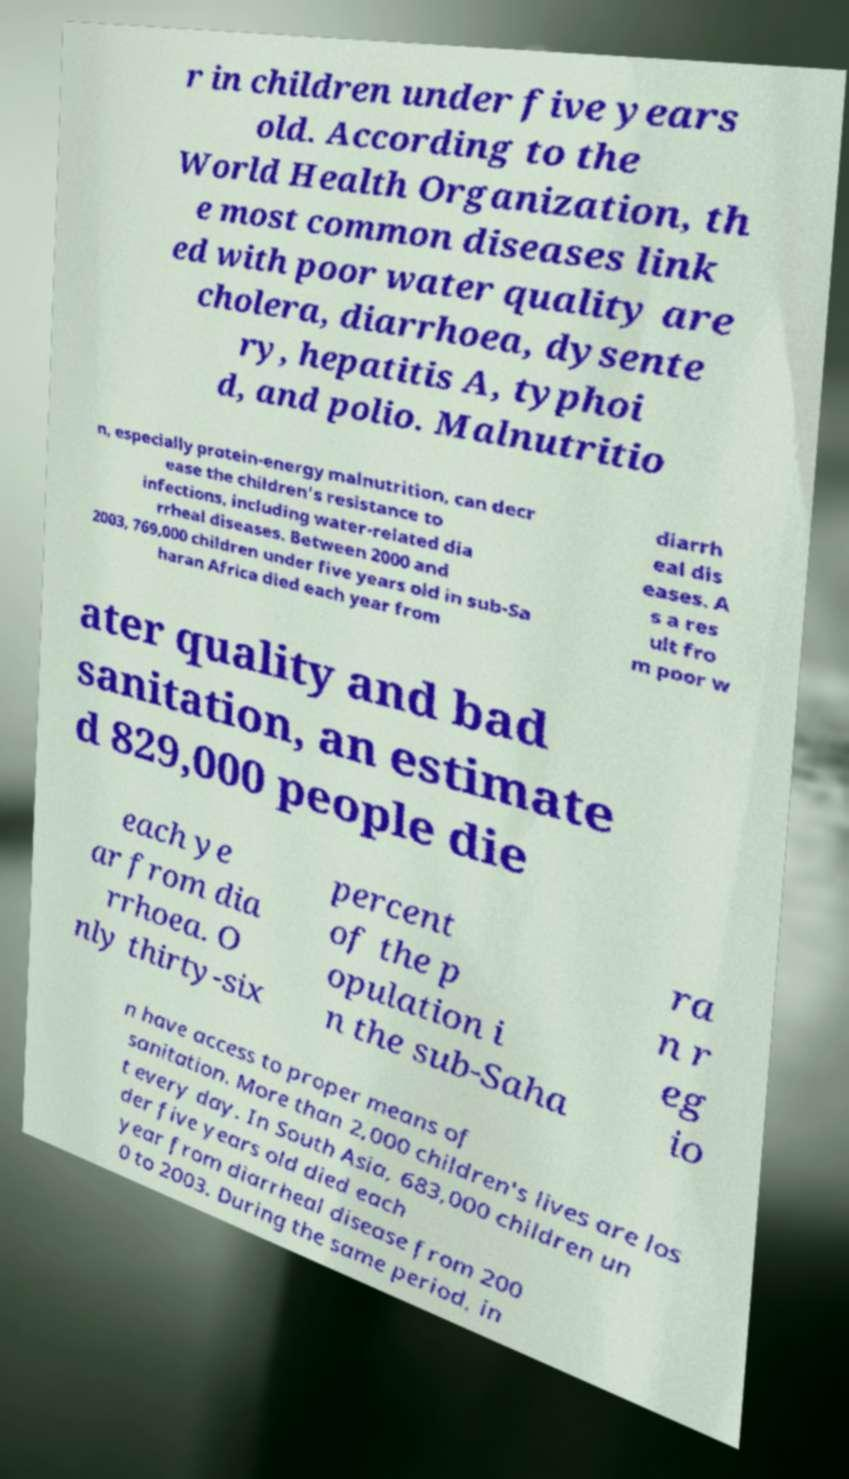For documentation purposes, I need the text within this image transcribed. Could you provide that? r in children under five years old. According to the World Health Organization, th e most common diseases link ed with poor water quality are cholera, diarrhoea, dysente ry, hepatitis A, typhoi d, and polio. Malnutritio n, especially protein-energy malnutrition, can decr ease the children's resistance to infections, including water-related dia rrheal diseases. Between 2000 and 2003, 769,000 children under five years old in sub-Sa haran Africa died each year from diarrh eal dis eases. A s a res ult fro m poor w ater quality and bad sanitation, an estimate d 829,000 people die each ye ar from dia rrhoea. O nly thirty-six percent of the p opulation i n the sub-Saha ra n r eg io n have access to proper means of sanitation. More than 2,000 children's lives are los t every day. In South Asia, 683,000 children un der five years old died each year from diarrheal disease from 200 0 to 2003. During the same period, in 